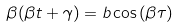<formula> <loc_0><loc_0><loc_500><loc_500>\beta ( \beta t + \gamma ) = b \cos { ( \beta \tau ) }</formula> 